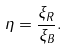<formula> <loc_0><loc_0><loc_500><loc_500>\eta = \frac { \xi _ { R } } { \xi _ { B } } .</formula> 